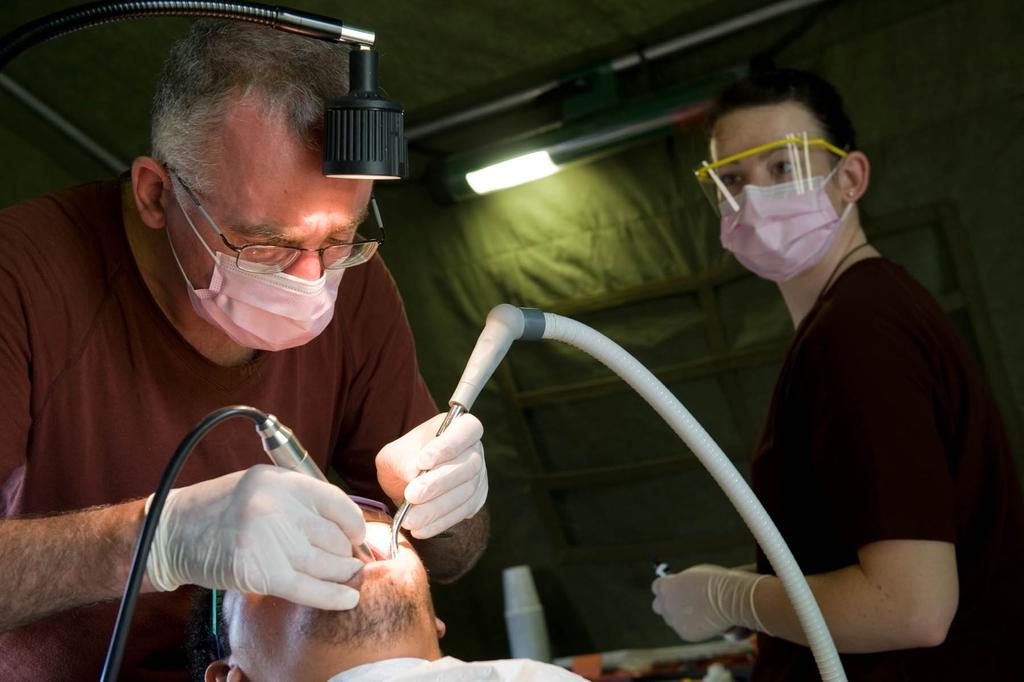In one or two sentences, can you explain what this image depicts? On the right side of the image I can see a person wearing a mask and holding the object. On the right side of the image I can see I can see a woman wearing a mask. 